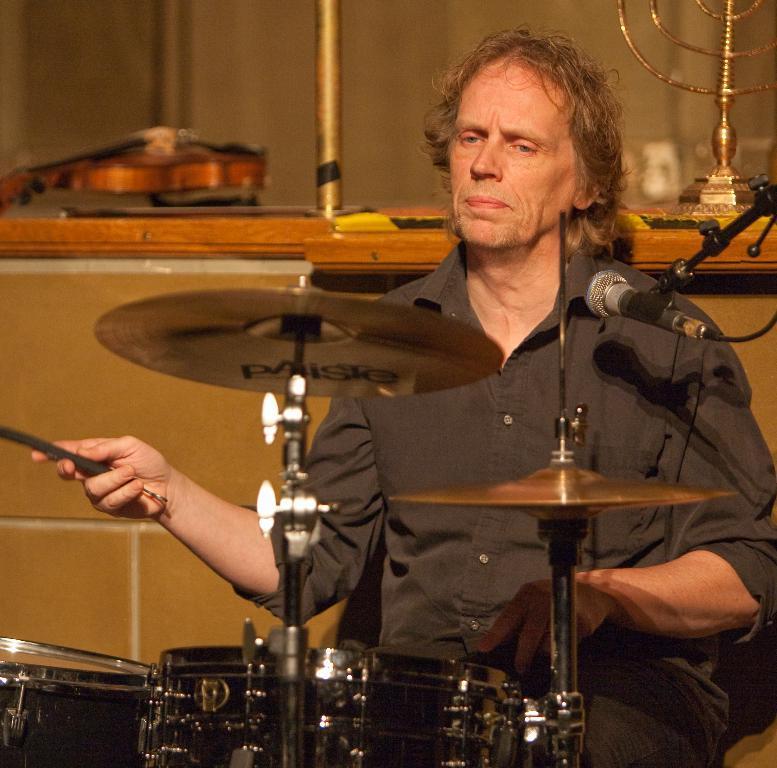Can you describe this image briefly? In the center of the image we can see a man sitting and playing a band. In the background there are musical instruments placed on the wall. 